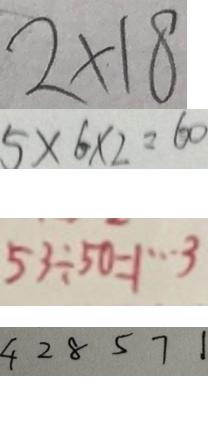<formula> <loc_0><loc_0><loc_500><loc_500>2 \times 1 8 
 5 \times 6 \times 2 = 6 0 
 5 3 \div 5 0 = 1 \cdots 3 
 4 2 8 5 7 1</formula> 